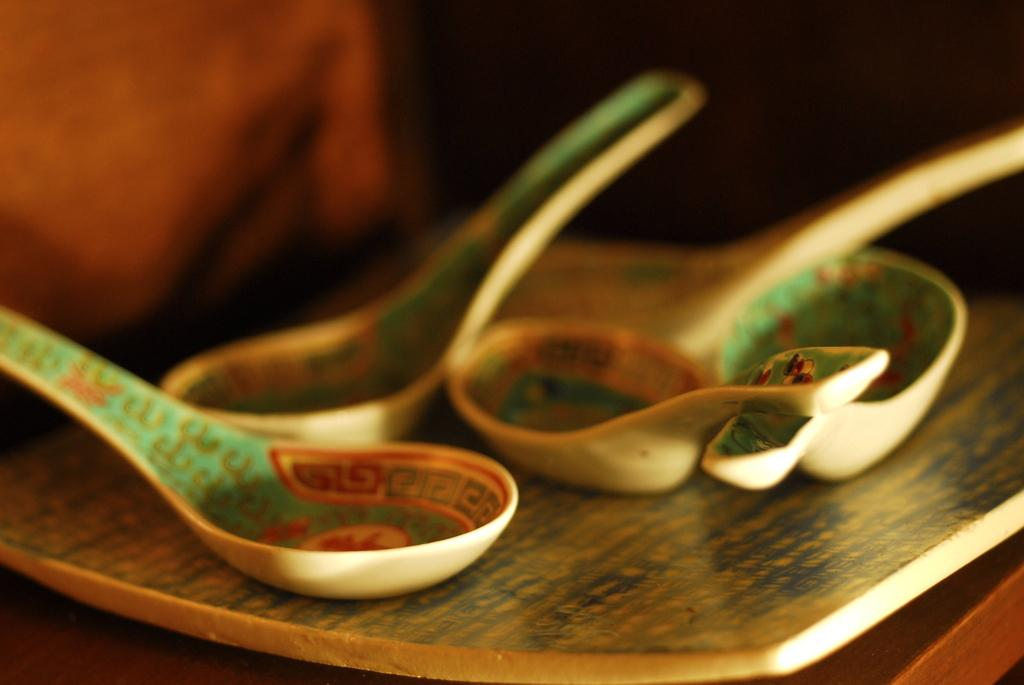What is present on the table in the image? There is a plate and spoons on the table in the image. What is the location of the table in the image? The table is inside a room, as suggested by the image. How many babies are present in the image? There are no babies present in the image; it only features a plate and spoons on a table. What is the temper of the plate in the image? The plate does not have a temper, as it is an inanimate object. 